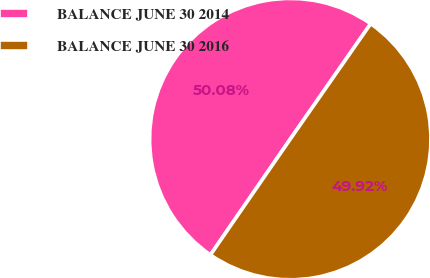Convert chart. <chart><loc_0><loc_0><loc_500><loc_500><pie_chart><fcel>BALANCE JUNE 30 2014<fcel>BALANCE JUNE 30 2016<nl><fcel>50.08%<fcel>49.92%<nl></chart> 